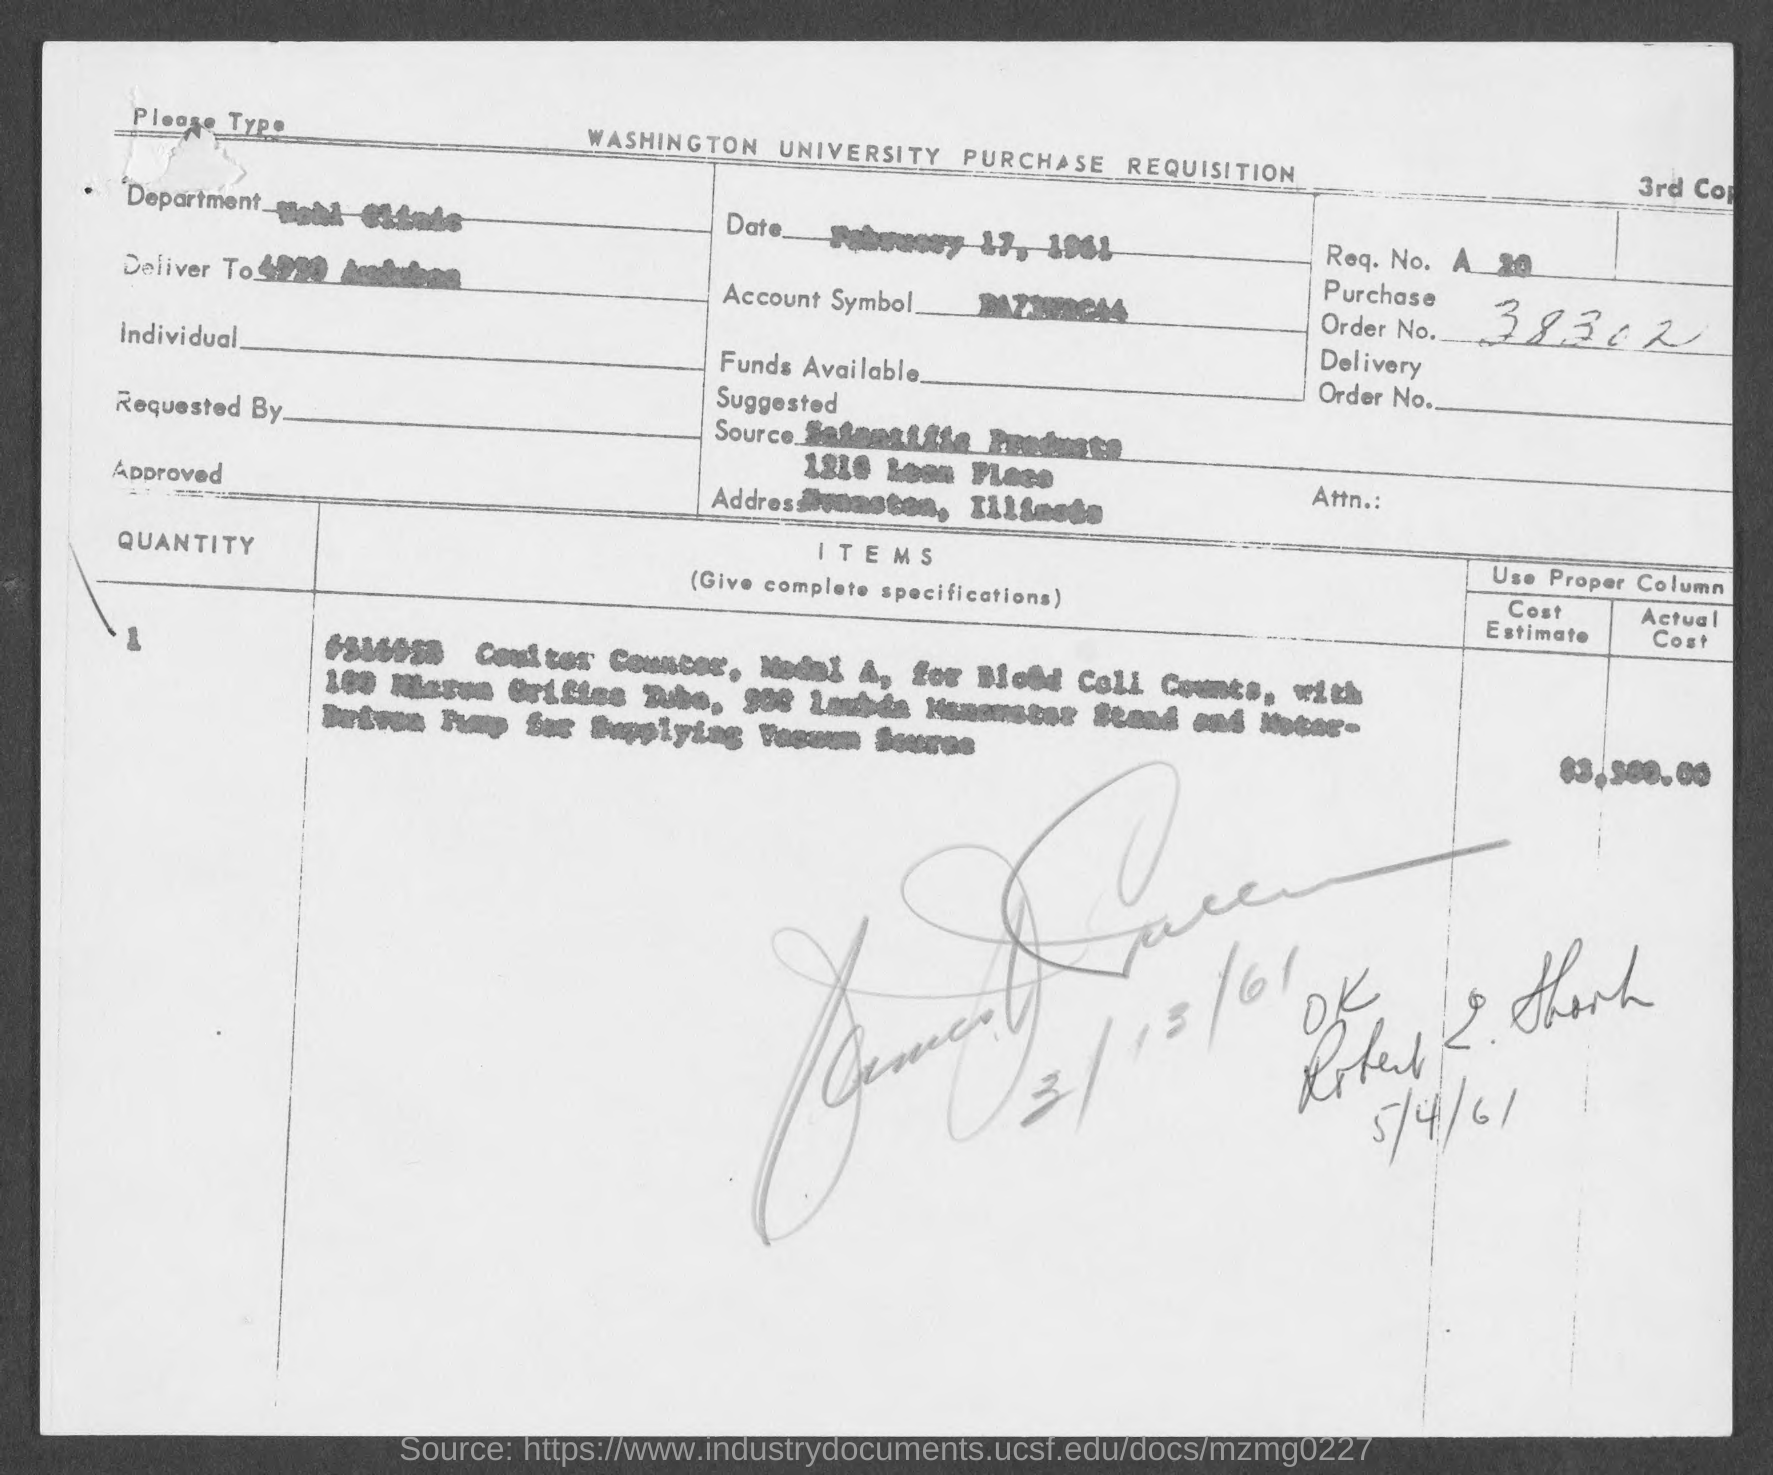What is the Date?
Your answer should be compact. February 17, 1961. What is the Order No.?
Provide a short and direct response. 38302. 